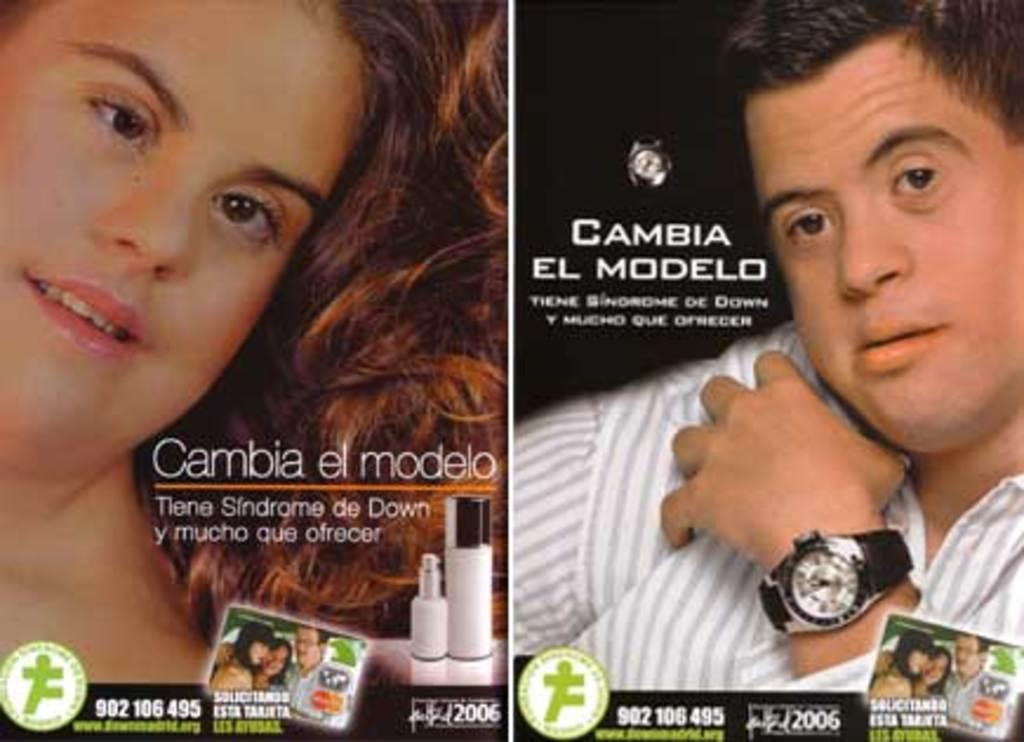Provide a one-sentence caption for the provided image. Two ads tell us that people with Down's Syndrome have much to offer. 